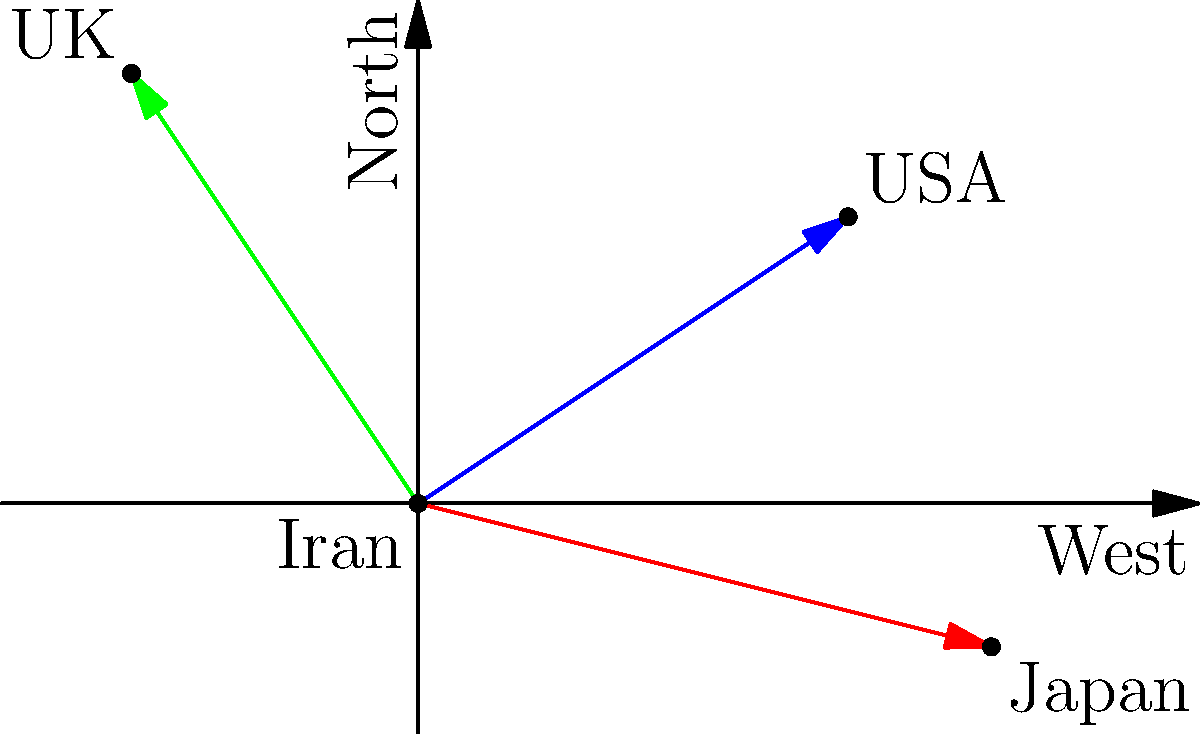During the Shah's reign, Iran's oil exports to three major countries are represented by vectors in the given diagram. If the magnitude of each vector represents the relative volume of oil exports (in million barrels per day), and the USA vector has a magnitude of $\sqrt{13}$ million barrels per day, what is the total volume of oil exports to all three countries combined? To solve this problem, we need to follow these steps:

1. Identify the vectors:
   - Iran to USA: $\vec{a} = (3, 2)$
   - Iran to Japan: $\vec{b} = (4, -1)$
   - Iran to UK: $\vec{c} = (-2, 3)$

2. Calculate the magnitude of the USA vector:
   $|\vec{a}| = \sqrt{3^2 + 2^2} = \sqrt{13}$

3. We're given that the USA vector magnitude represents $\sqrt{13}$ million barrels per day. So, each unit in our vector space represents 1 million barrels per day.

4. Calculate the magnitudes of the other vectors:
   - Japan: $|\vec{b}| = \sqrt{4^2 + (-1)^2} = \sqrt{17}$
   - UK: $|\vec{c}| = \sqrt{(-2)^2 + 3^2} = \sqrt{13}$

5. Sum up all the magnitudes:
   Total exports = $|\vec{a}| + |\vec{b}| + |\vec{c}|$
                 = $\sqrt{13} + \sqrt{17} + \sqrt{13}$
                 = $2\sqrt{13} + \sqrt{17}$

Therefore, the total volume of oil exports to all three countries is $2\sqrt{13} + \sqrt{17}$ million barrels per day.
Answer: $2\sqrt{13} + \sqrt{17}$ million barrels per day 